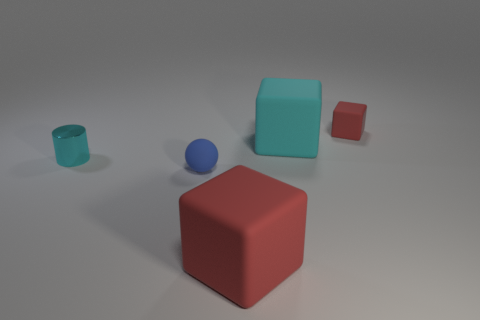Subtract all cyan blocks. How many blocks are left? 2 Subtract all green balls. How many red cubes are left? 2 Add 3 tiny red cubes. How many objects exist? 8 Subtract all blocks. How many objects are left? 2 Add 3 tiny red rubber cubes. How many tiny red rubber cubes are left? 4 Add 1 large cyan things. How many large cyan things exist? 2 Subtract 0 yellow spheres. How many objects are left? 5 Subtract all purple blocks. Subtract all red cylinders. How many blocks are left? 3 Subtract all tiny blue things. Subtract all red matte cubes. How many objects are left? 2 